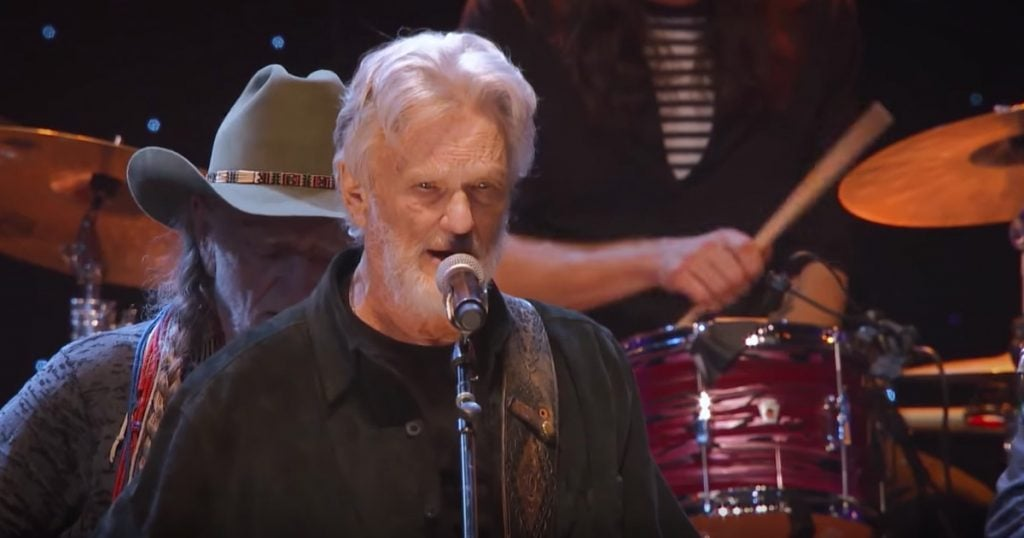What can you infer about the time period this performance might be emulating based on the image? Based on the musicians' attire and the classic instruments present, it seems that this performance might be emulating a mid-20th century era, particularly the 1950s to 1970s. The style of the cowboy hat, the casual wear of the drummer, and the overall aesthetics reflect a time when country, folk, and rock music were incredibly popular. How does the attire of the musicians influence the audience's perception of their music? The attire of the musicians plays a significant role in shaping the audience's perception of their music. The cowboy hat and casual outfits typically associated with country and folk genres immediately set expectations for a certain style of music that is nostalgic, rooted in tradition, and often tells stories of everyday life and emotions. This traditional image can connect viewers to the rich cultural heritage of these genres, making the performance feel more authentic and grounded. 